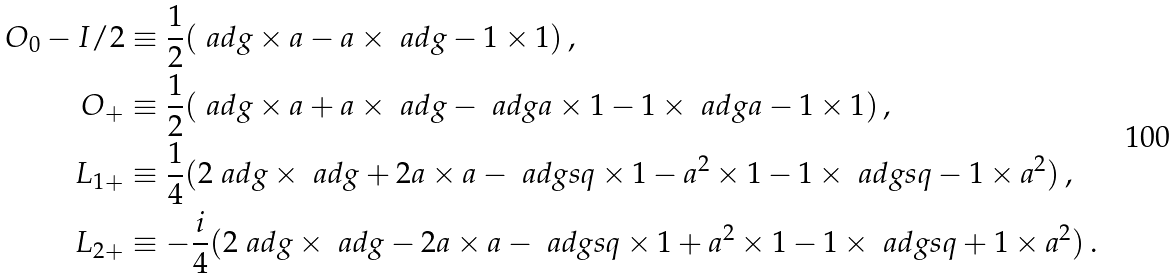Convert formula to latex. <formula><loc_0><loc_0><loc_500><loc_500>O _ { 0 } - I / 2 & \equiv \frac { 1 } { 2 } ( \ a d g \times a - a \times \ a d g - 1 \times 1 ) \, , \\ O _ { + } & \equiv \frac { 1 } { 2 } ( \ a d g \times a + a \times \ a d g - \ a d g a \times 1 - 1 \times \ a d g a - 1 \times 1 ) \, , \\ L _ { 1 + } & \equiv \frac { 1 } { 4 } ( 2 \ a d g \times \ a d g + 2 a \times a - \ a d g s q \times 1 - a ^ { 2 } \times 1 - 1 \times \ a d g s q - 1 \times a ^ { 2 } ) \, , \\ L _ { 2 + } & \equiv - \frac { i } { 4 } ( 2 \ a d g \times \ a d g - 2 a \times a - \ a d g s q \times 1 + a ^ { 2 } \times 1 - 1 \times \ a d g s q + 1 \times a ^ { 2 } ) \, .</formula> 